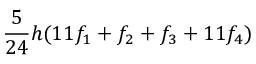Convert formula to latex. <formula><loc_0><loc_0><loc_500><loc_500>{ \frac { 5 } { 2 4 } } h ( 1 1 f _ { 1 } + f _ { 2 } + f _ { 3 } + 1 1 f _ { 4 } )</formula> 